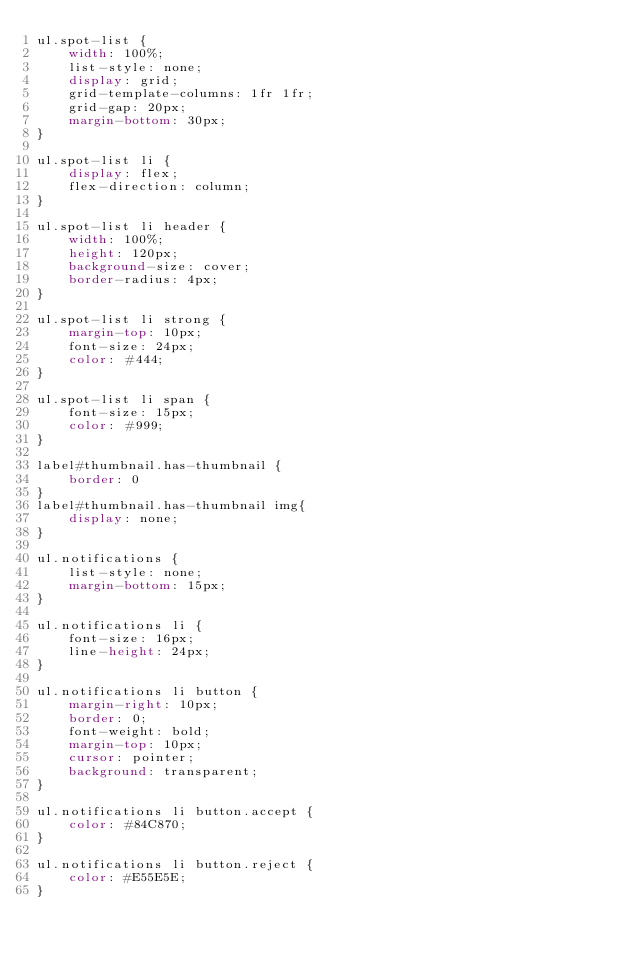<code> <loc_0><loc_0><loc_500><loc_500><_CSS_>ul.spot-list {
    width: 100%;
    list-style: none;
    display: grid;
    grid-template-columns: 1fr 1fr;
    grid-gap: 20px;
    margin-bottom: 30px;
}

ul.spot-list li {
    display: flex;
    flex-direction: column;
}

ul.spot-list li header {
    width: 100%;
    height: 120px;
    background-size: cover;
    border-radius: 4px;
}

ul.spot-list li strong {
    margin-top: 10px;
    font-size: 24px;
    color: #444;
}

ul.spot-list li span {
    font-size: 15px;
    color: #999;
}

label#thumbnail.has-thumbnail {
    border: 0
}
label#thumbnail.has-thumbnail img{
    display: none;
}

ul.notifications {
    list-style: none;
    margin-bottom: 15px;
}

ul.notifications li {
    font-size: 16px;
    line-height: 24px;
}

ul.notifications li button {
    margin-right: 10px;
    border: 0;
    font-weight: bold;
    margin-top: 10px;
    cursor: pointer;
    background: transparent;
}

ul.notifications li button.accept {
    color: #84C870;
}

ul.notifications li button.reject {
    color: #E55E5E;
}</code> 